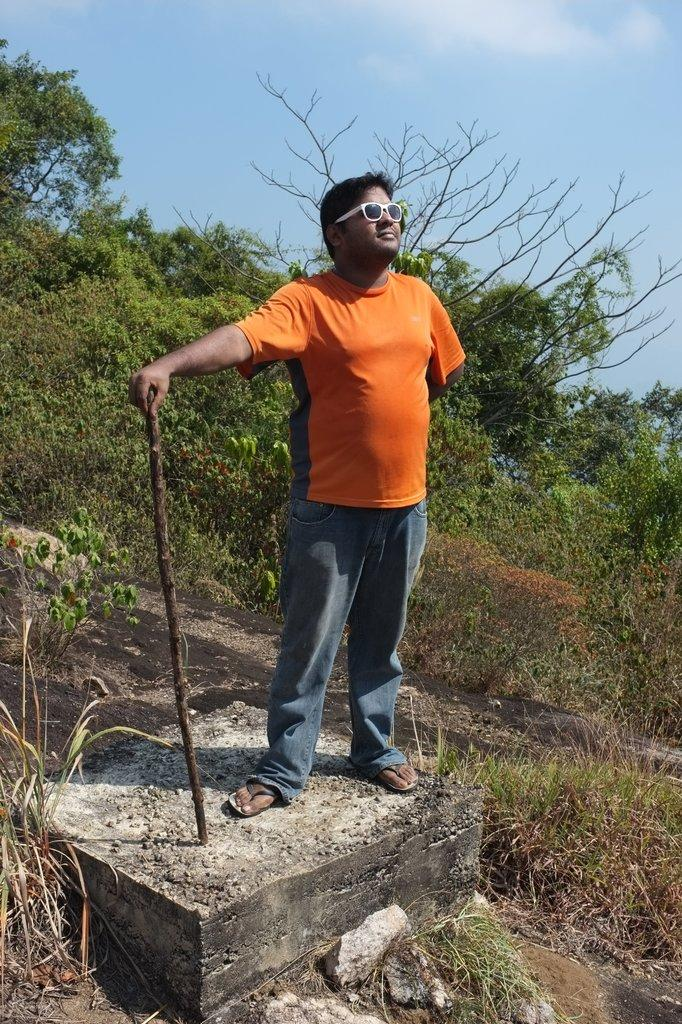What is the man in the image doing? The man is standing in the image. What is the man holding in the image? The man is holding a stick in the image. What is the man standing on in the image? The man is standing on a rock in the image. What can be seen in the background of the image? There are trees and plants in the background of the image. What is the condition of the sky in the image? The sky is clear in the image. What type of gold jewelry is the man wearing in the image? There is no gold jewelry visible on the man in the image. What is the man's relationship to the person taking the photo in the image? The provided facts do not mention any relationship between the man and the person taking the photo, so we cannot determine the man's relationship to the photographer. 